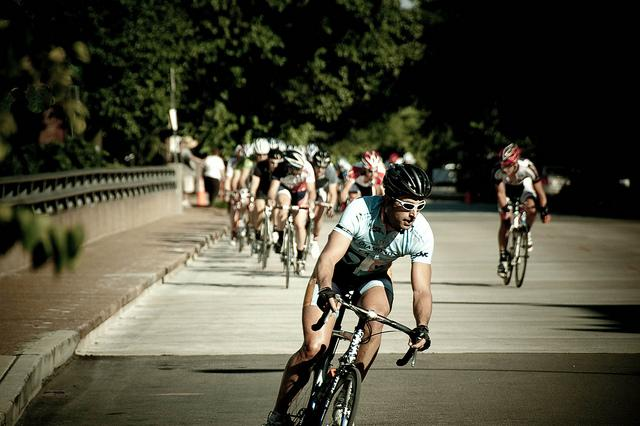What is the most likely reason the street is filled with bicyclists?

Choices:
A) training
B) race
C) parade
D) protest race 